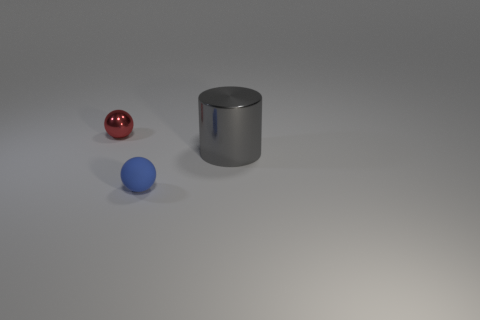Add 2 big shiny objects. How many objects exist? 5 Subtract all spheres. How many objects are left? 1 Subtract 2 balls. How many balls are left? 0 Subtract all red balls. How many balls are left? 1 Subtract 0 purple blocks. How many objects are left? 3 Subtract all brown cylinders. Subtract all cyan blocks. How many cylinders are left? 1 Subtract all yellow blocks. How many gray spheres are left? 0 Subtract all large yellow matte spheres. Subtract all tiny matte objects. How many objects are left? 2 Add 3 large gray metallic objects. How many large gray metallic objects are left? 4 Add 3 small blue matte cylinders. How many small blue matte cylinders exist? 3 